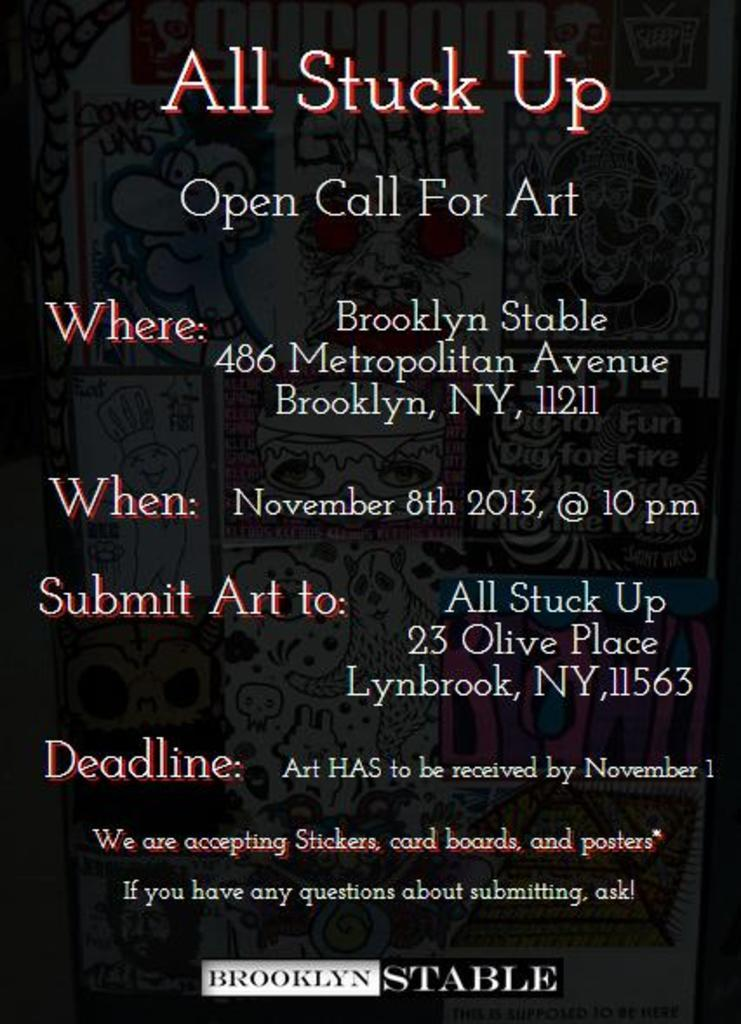<image>
Give a short and clear explanation of the subsequent image. A flyer for an event call All Stuck Up taking place on November 8th in Brooklyn New York. 